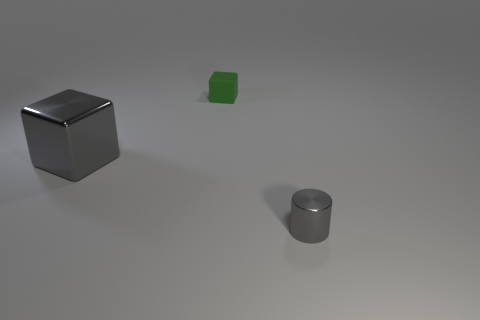Add 3 tiny brown spheres. How many objects exist? 6 Subtract all cylinders. How many objects are left? 2 Add 1 gray shiny cubes. How many gray shiny cubes exist? 2 Subtract 1 green cubes. How many objects are left? 2 Subtract all big purple matte things. Subtract all tiny objects. How many objects are left? 1 Add 3 tiny gray things. How many tiny gray things are left? 4 